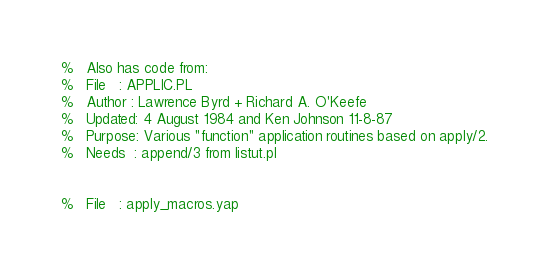<code> <loc_0><loc_0><loc_500><loc_500><_Prolog_>%   Also has code from:
%   File   : APPLIC.PL
%   Author : Lawrence Byrd + Richard A. O'Keefe
%   Updated: 4 August 1984 and Ken Johnson 11-8-87
%   Purpose: Various "function" application routines based on apply/2.
%   Needs  : append/3 from listut.pl


%   File   : apply_macros.yap</code> 